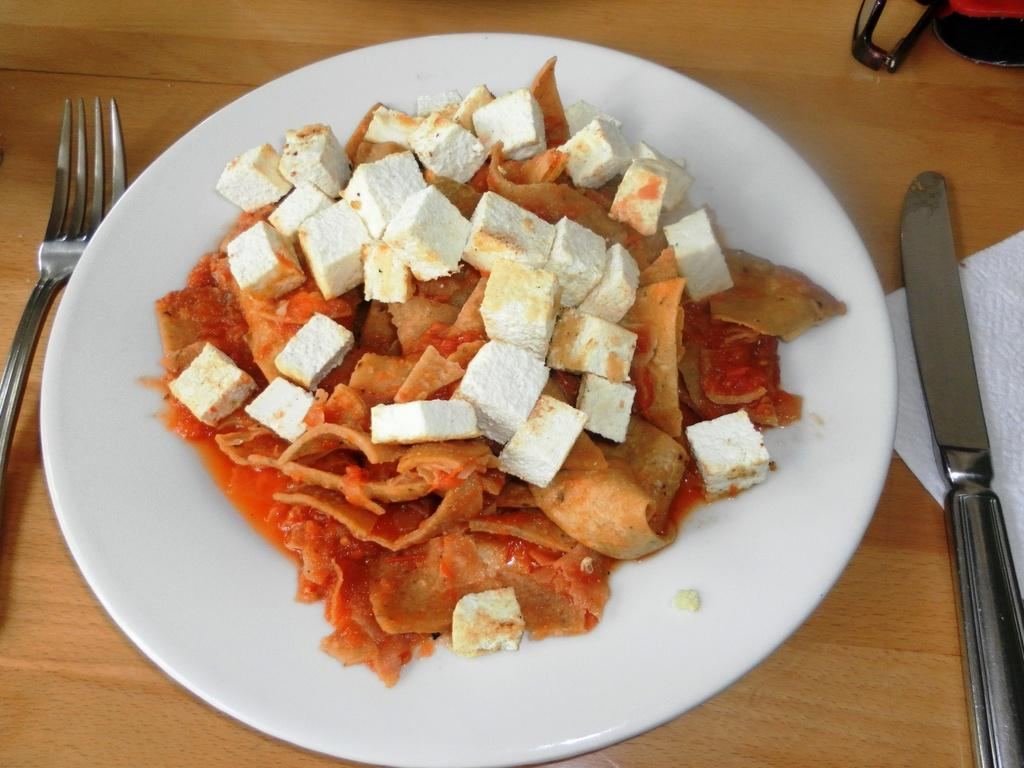What is on the serving plate in the image? There is food on the serving plate in the image. What can be used to eat the food on the plate? Cutlery is visible in the image. What might be used for wiping or drying hands in the image? There is a paper napkin in the image. Where are all these items placed in the image? All of these items are placed on a table. How many apples are being pulled off the tree in the image? There are no apples or trees present in the image; it features a serving plate with food, cutlery, a paper napkin, and a table. 